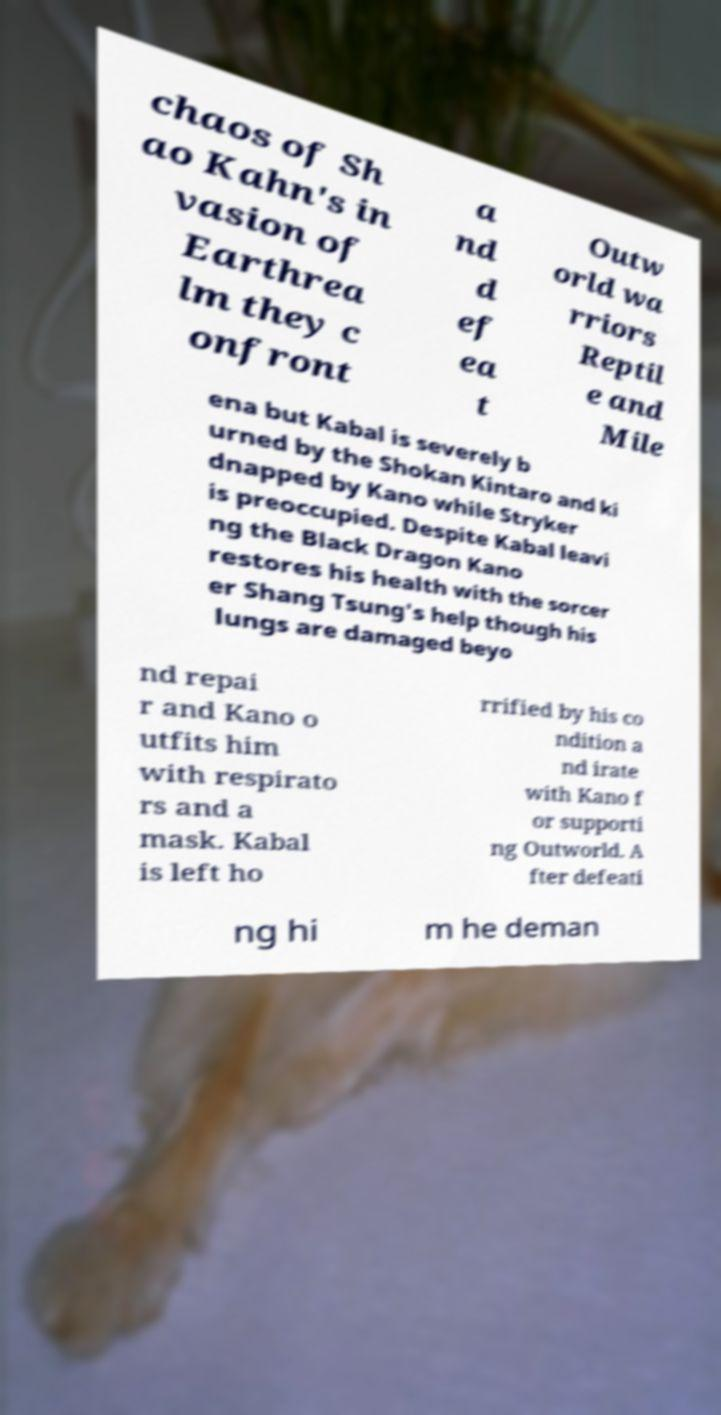Please read and relay the text visible in this image. What does it say? chaos of Sh ao Kahn's in vasion of Earthrea lm they c onfront a nd d ef ea t Outw orld wa rriors Reptil e and Mile ena but Kabal is severely b urned by the Shokan Kintaro and ki dnapped by Kano while Stryker is preoccupied. Despite Kabal leavi ng the Black Dragon Kano restores his health with the sorcer er Shang Tsung's help though his lungs are damaged beyo nd repai r and Kano o utfits him with respirato rs and a mask. Kabal is left ho rrified by his co ndition a nd irate with Kano f or supporti ng Outworld. A fter defeati ng hi m he deman 